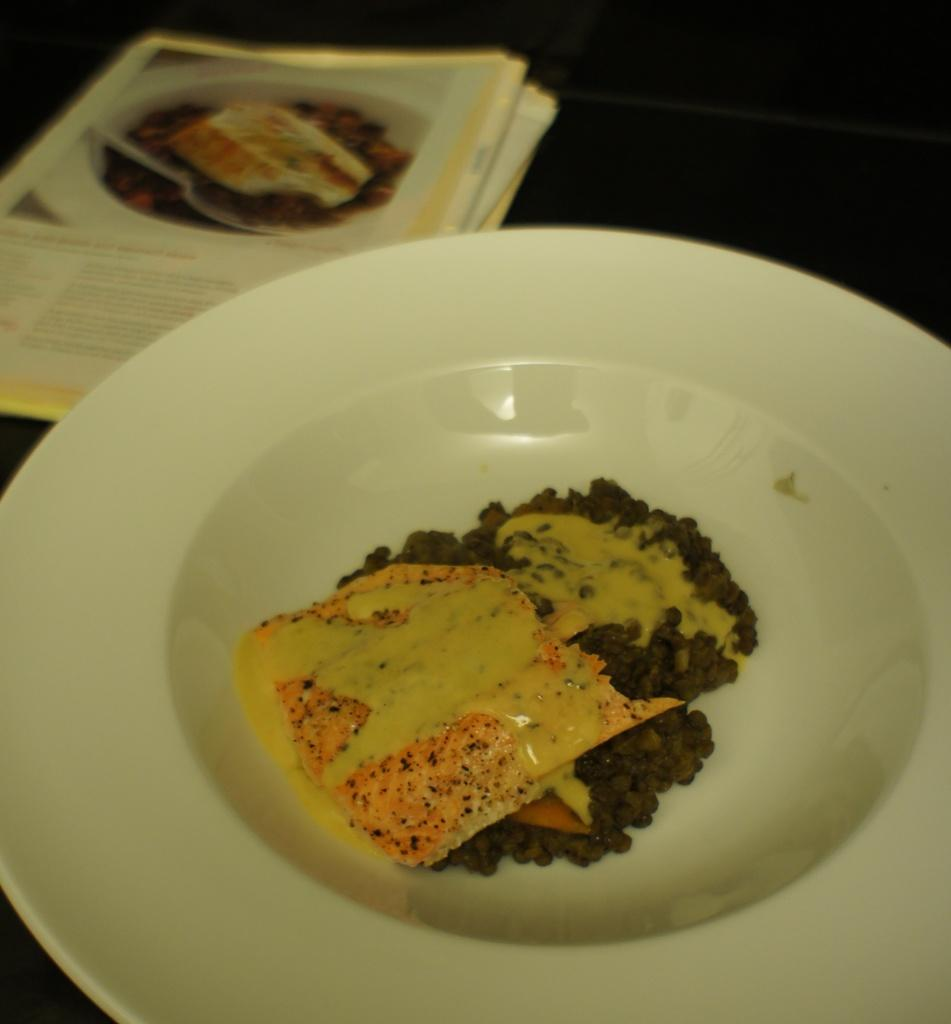What is located in the center of the image? There is a plate in the center of the image. What can be seen on the left side of the image? There are papers on the left side of the image. What type of manager is depicted in the image? There is no manager present in the image; it only features a plate and papers. What is the selection of papers available in the image? The image only shows papers, but it does not provide any information about the content or selection of those papers. 